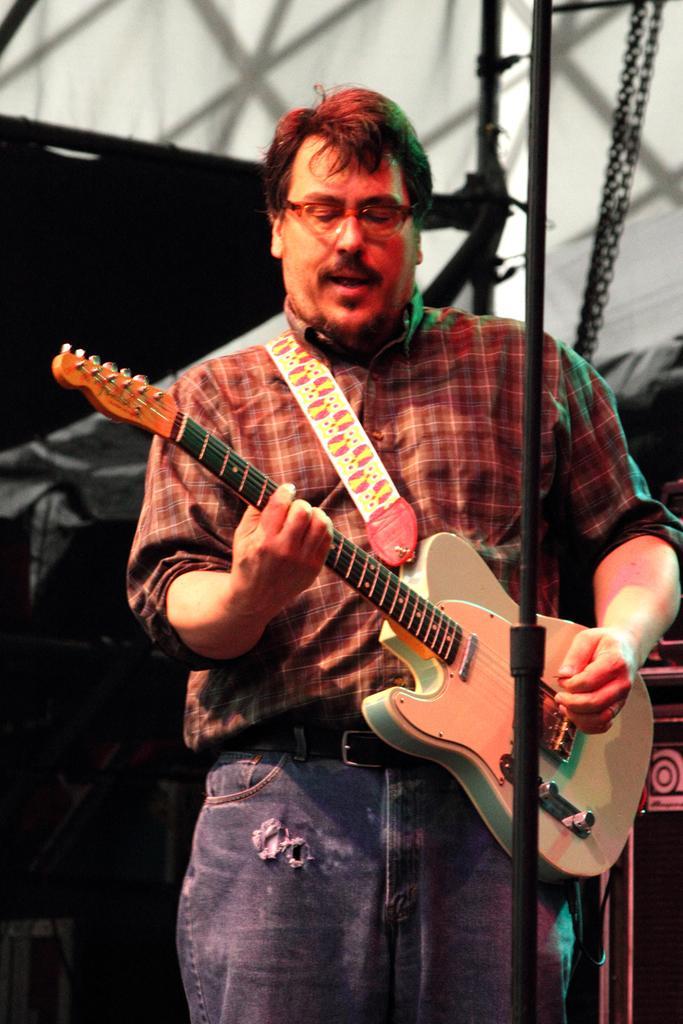Could you give a brief overview of what you see in this image? there is a man standing on stage is playing a guitar. 